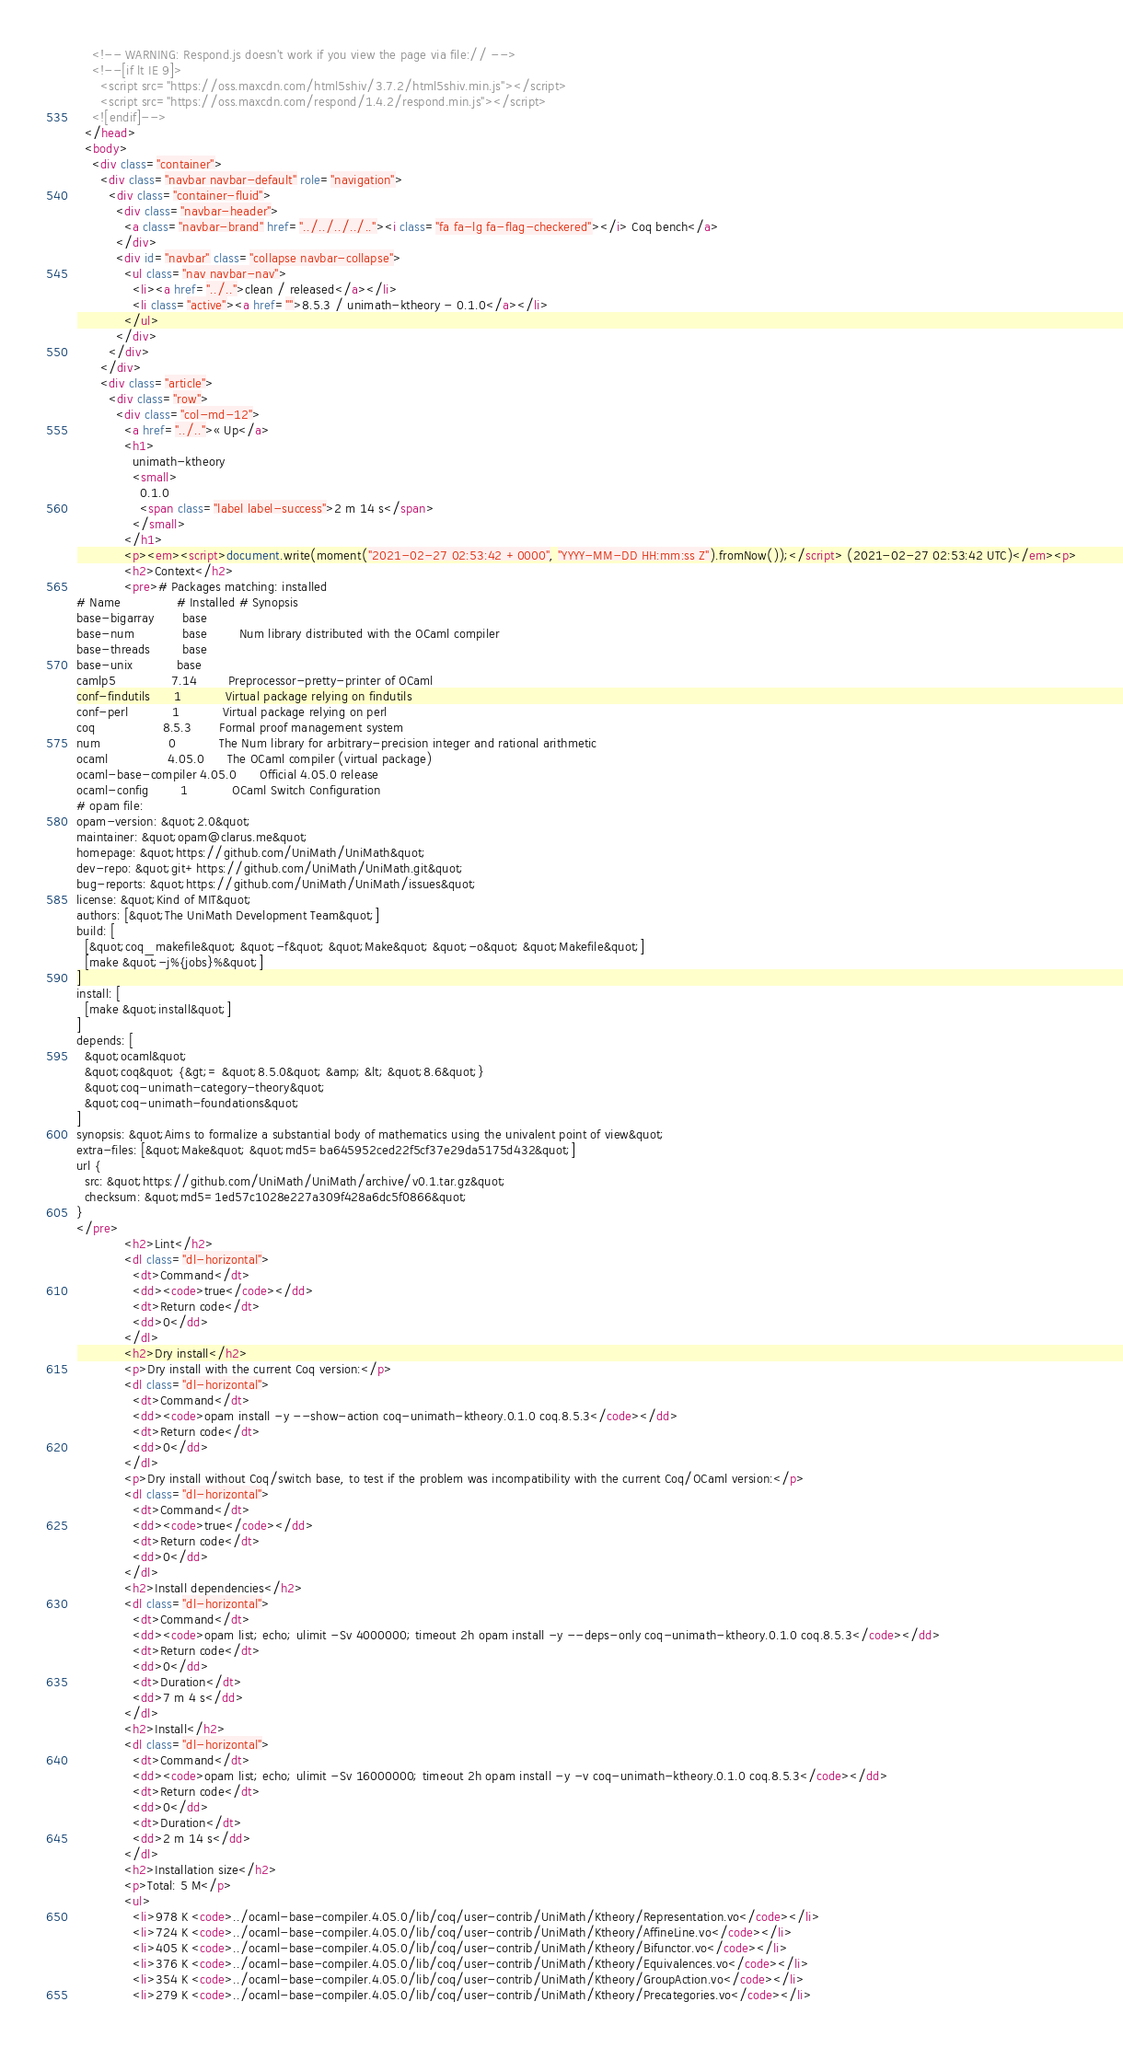Convert code to text. <code><loc_0><loc_0><loc_500><loc_500><_HTML_>    <!-- WARNING: Respond.js doesn't work if you view the page via file:// -->
    <!--[if lt IE 9]>
      <script src="https://oss.maxcdn.com/html5shiv/3.7.2/html5shiv.min.js"></script>
      <script src="https://oss.maxcdn.com/respond/1.4.2/respond.min.js"></script>
    <![endif]-->
  </head>
  <body>
    <div class="container">
      <div class="navbar navbar-default" role="navigation">
        <div class="container-fluid">
          <div class="navbar-header">
            <a class="navbar-brand" href="../../../../.."><i class="fa fa-lg fa-flag-checkered"></i> Coq bench</a>
          </div>
          <div id="navbar" class="collapse navbar-collapse">
            <ul class="nav navbar-nav">
              <li><a href="../..">clean / released</a></li>
              <li class="active"><a href="">8.5.3 / unimath-ktheory - 0.1.0</a></li>
            </ul>
          </div>
        </div>
      </div>
      <div class="article">
        <div class="row">
          <div class="col-md-12">
            <a href="../..">« Up</a>
            <h1>
              unimath-ktheory
              <small>
                0.1.0
                <span class="label label-success">2 m 14 s</span>
              </small>
            </h1>
            <p><em><script>document.write(moment("2021-02-27 02:53:42 +0000", "YYYY-MM-DD HH:mm:ss Z").fromNow());</script> (2021-02-27 02:53:42 UTC)</em><p>
            <h2>Context</h2>
            <pre># Packages matching: installed
# Name              # Installed # Synopsis
base-bigarray       base
base-num            base        Num library distributed with the OCaml compiler
base-threads        base
base-unix           base
camlp5              7.14        Preprocessor-pretty-printer of OCaml
conf-findutils      1           Virtual package relying on findutils
conf-perl           1           Virtual package relying on perl
coq                 8.5.3       Formal proof management system
num                 0           The Num library for arbitrary-precision integer and rational arithmetic
ocaml               4.05.0      The OCaml compiler (virtual package)
ocaml-base-compiler 4.05.0      Official 4.05.0 release
ocaml-config        1           OCaml Switch Configuration
# opam file:
opam-version: &quot;2.0&quot;
maintainer: &quot;opam@clarus.me&quot;
homepage: &quot;https://github.com/UniMath/UniMath&quot;
dev-repo: &quot;git+https://github.com/UniMath/UniMath.git&quot;
bug-reports: &quot;https://github.com/UniMath/UniMath/issues&quot;
license: &quot;Kind of MIT&quot;
authors: [&quot;The UniMath Development Team&quot;]
build: [
  [&quot;coq_makefile&quot; &quot;-f&quot; &quot;Make&quot; &quot;-o&quot; &quot;Makefile&quot;]
  [make &quot;-j%{jobs}%&quot;]
]
install: [
  [make &quot;install&quot;]
]
depends: [
  &quot;ocaml&quot;
  &quot;coq&quot; {&gt;= &quot;8.5.0&quot; &amp; &lt; &quot;8.6&quot;}
  &quot;coq-unimath-category-theory&quot;
  &quot;coq-unimath-foundations&quot;
]
synopsis: &quot;Aims to formalize a substantial body of mathematics using the univalent point of view&quot;
extra-files: [&quot;Make&quot; &quot;md5=ba645952ced22f5cf37e29da5175d432&quot;]
url {
  src: &quot;https://github.com/UniMath/UniMath/archive/v0.1.tar.gz&quot;
  checksum: &quot;md5=1ed57c1028e227a309f428a6dc5f0866&quot;
}
</pre>
            <h2>Lint</h2>
            <dl class="dl-horizontal">
              <dt>Command</dt>
              <dd><code>true</code></dd>
              <dt>Return code</dt>
              <dd>0</dd>
            </dl>
            <h2>Dry install</h2>
            <p>Dry install with the current Coq version:</p>
            <dl class="dl-horizontal">
              <dt>Command</dt>
              <dd><code>opam install -y --show-action coq-unimath-ktheory.0.1.0 coq.8.5.3</code></dd>
              <dt>Return code</dt>
              <dd>0</dd>
            </dl>
            <p>Dry install without Coq/switch base, to test if the problem was incompatibility with the current Coq/OCaml version:</p>
            <dl class="dl-horizontal">
              <dt>Command</dt>
              <dd><code>true</code></dd>
              <dt>Return code</dt>
              <dd>0</dd>
            </dl>
            <h2>Install dependencies</h2>
            <dl class="dl-horizontal">
              <dt>Command</dt>
              <dd><code>opam list; echo; ulimit -Sv 4000000; timeout 2h opam install -y --deps-only coq-unimath-ktheory.0.1.0 coq.8.5.3</code></dd>
              <dt>Return code</dt>
              <dd>0</dd>
              <dt>Duration</dt>
              <dd>7 m 4 s</dd>
            </dl>
            <h2>Install</h2>
            <dl class="dl-horizontal">
              <dt>Command</dt>
              <dd><code>opam list; echo; ulimit -Sv 16000000; timeout 2h opam install -y -v coq-unimath-ktheory.0.1.0 coq.8.5.3</code></dd>
              <dt>Return code</dt>
              <dd>0</dd>
              <dt>Duration</dt>
              <dd>2 m 14 s</dd>
            </dl>
            <h2>Installation size</h2>
            <p>Total: 5 M</p>
            <ul>
              <li>978 K <code>../ocaml-base-compiler.4.05.0/lib/coq/user-contrib/UniMath/Ktheory/Representation.vo</code></li>
              <li>724 K <code>../ocaml-base-compiler.4.05.0/lib/coq/user-contrib/UniMath/Ktheory/AffineLine.vo</code></li>
              <li>405 K <code>../ocaml-base-compiler.4.05.0/lib/coq/user-contrib/UniMath/Ktheory/Bifunctor.vo</code></li>
              <li>376 K <code>../ocaml-base-compiler.4.05.0/lib/coq/user-contrib/UniMath/Ktheory/Equivalences.vo</code></li>
              <li>354 K <code>../ocaml-base-compiler.4.05.0/lib/coq/user-contrib/UniMath/Ktheory/GroupAction.vo</code></li>
              <li>279 K <code>../ocaml-base-compiler.4.05.0/lib/coq/user-contrib/UniMath/Ktheory/Precategories.vo</code></li></code> 